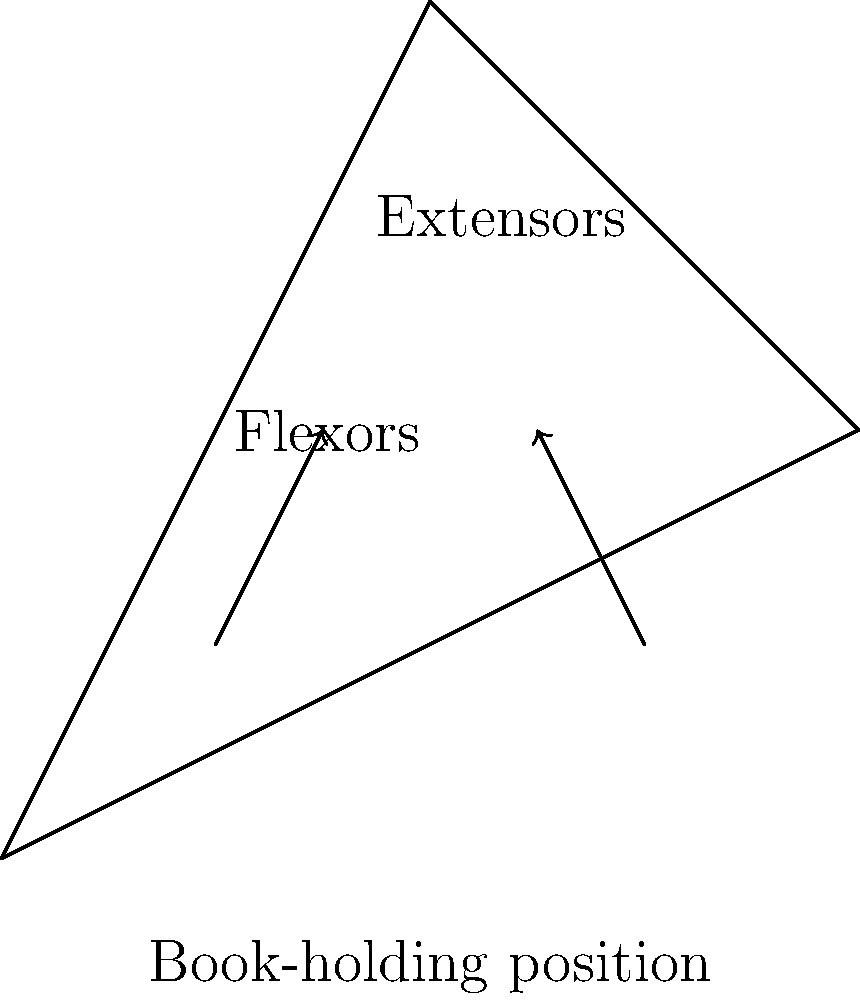In the context of a librarian holding a book, which muscle group in the forearm is primarily responsible for maintaining a stable grip on the book, and how does this change when transitioning from a palm-up to a palm-down position? To answer this question, let's break down the biomechanics of holding a book:

1. Palm-up position (supination):
   - In this position, the primary muscles engaged are the flexor muscles of the forearm.
   - The flexor digitorum superficialis and flexor digitorum profundus are mainly responsible for gripping the book.
   - The biceps brachii also assists in maintaining the supinated position.

2. Palm-down position (pronation):
   - When transitioning to this position, the extensor muscles become more engaged.
   - The extensor digitorum and extensor carpi muscles work to maintain finger extension and wrist stability.
   - The pronator teres and pronator quadratus muscles are activated to rotate the forearm.

3. Transition from palm-up to palm-down:
   - As the hand rotates, there's a shift in muscle activation from flexors to extensors.
   - The grip strength typically decreases in the pronated position compared to the supinated position.
   - The brachioradialis muscle plays a role in both positions, helping to flex the elbow.

4. Stabilizing muscles:
   - Throughout both positions, the brachioradialis and other elbow flexors work to maintain the arm's position.
   - The rotator cuff muscles in the shoulder also engage to stabilize the upper arm.

In the context of a librarian holding books, understanding these muscle activation patterns can help in developing ergonomic strategies for prolonged book-handling tasks, potentially reducing fatigue and strain.
Answer: Flexor muscles in palm-up; shift to extensors in palm-down 